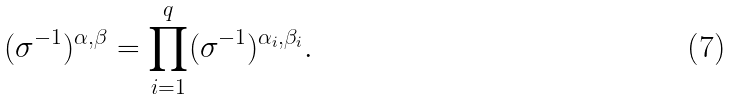<formula> <loc_0><loc_0><loc_500><loc_500>( \sigma ^ { - 1 } ) ^ { \alpha , \beta } = \prod _ { i = 1 } ^ { q } ( \sigma ^ { - 1 } ) ^ { \alpha _ { i } , \beta _ { i } } .</formula> 